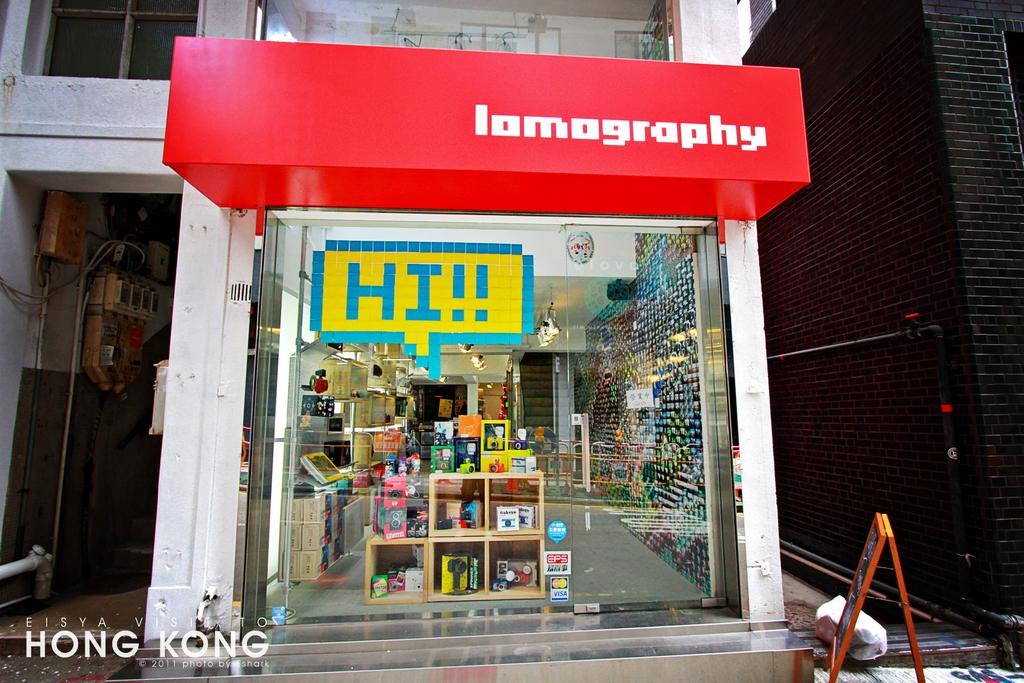Provide a one-sentence caption for the provided image. The oustide of a colourful and narrow shop called lamography in Hong Kong. 